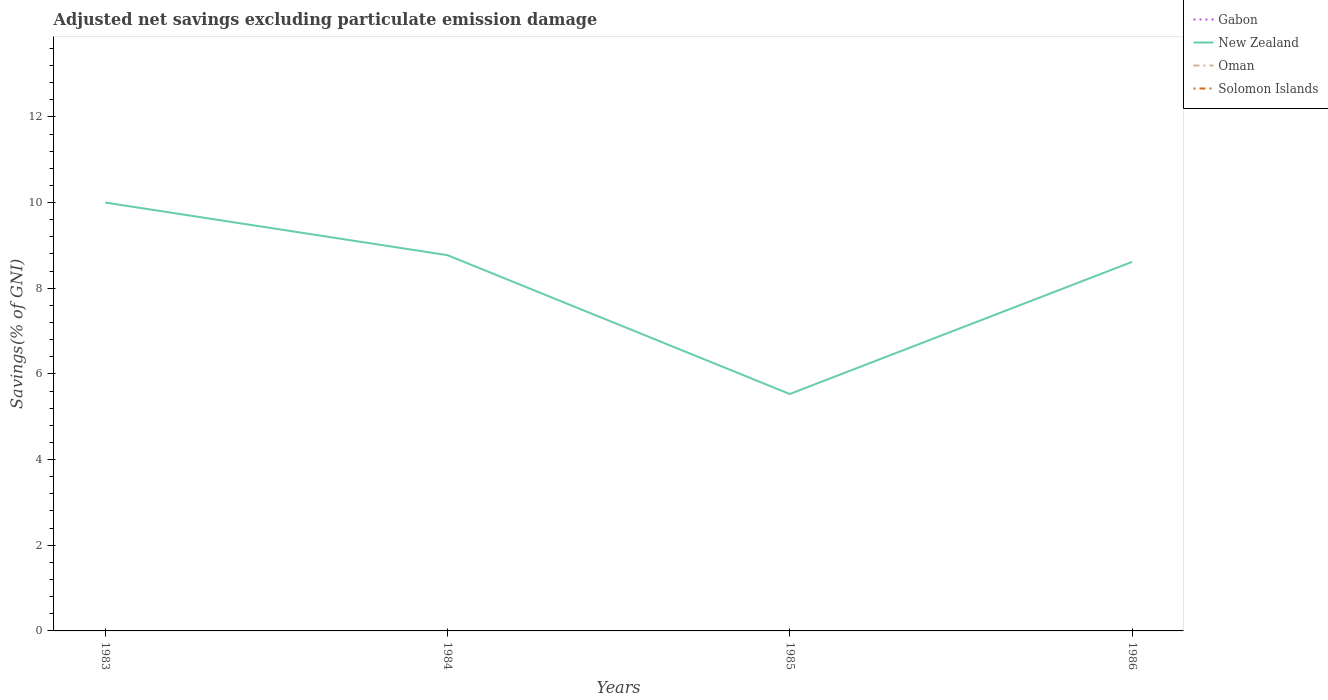Does the line corresponding to Gabon intersect with the line corresponding to New Zealand?
Your answer should be very brief. No. Across all years, what is the maximum adjusted net savings in New Zealand?
Your response must be concise. 5.53. What is the total adjusted net savings in New Zealand in the graph?
Make the answer very short. -3.08. What is the difference between the highest and the second highest adjusted net savings in Oman?
Provide a short and direct response. 0.01. Is the adjusted net savings in New Zealand strictly greater than the adjusted net savings in Solomon Islands over the years?
Provide a short and direct response. No. Are the values on the major ticks of Y-axis written in scientific E-notation?
Offer a very short reply. No. Does the graph contain any zero values?
Provide a succinct answer. Yes. Does the graph contain grids?
Your answer should be very brief. No. How many legend labels are there?
Keep it short and to the point. 4. How are the legend labels stacked?
Offer a very short reply. Vertical. What is the title of the graph?
Provide a short and direct response. Adjusted net savings excluding particulate emission damage. What is the label or title of the Y-axis?
Keep it short and to the point. Savings(% of GNI). What is the Savings(% of GNI) in Gabon in 1983?
Provide a short and direct response. 0. What is the Savings(% of GNI) in New Zealand in 1983?
Make the answer very short. 10. What is the Savings(% of GNI) in Oman in 1983?
Provide a succinct answer. 0. What is the Savings(% of GNI) in Gabon in 1984?
Keep it short and to the point. 0. What is the Savings(% of GNI) in New Zealand in 1984?
Your response must be concise. 8.77. What is the Savings(% of GNI) in Oman in 1984?
Your response must be concise. 0.01. What is the Savings(% of GNI) in Gabon in 1985?
Ensure brevity in your answer.  0. What is the Savings(% of GNI) in New Zealand in 1985?
Make the answer very short. 5.53. What is the Savings(% of GNI) of Gabon in 1986?
Provide a succinct answer. 0. What is the Savings(% of GNI) in New Zealand in 1986?
Ensure brevity in your answer.  8.62. What is the Savings(% of GNI) in Solomon Islands in 1986?
Ensure brevity in your answer.  0. Across all years, what is the maximum Savings(% of GNI) in New Zealand?
Make the answer very short. 10. Across all years, what is the maximum Savings(% of GNI) of Oman?
Provide a succinct answer. 0.01. Across all years, what is the minimum Savings(% of GNI) in New Zealand?
Offer a very short reply. 5.53. Across all years, what is the minimum Savings(% of GNI) in Oman?
Ensure brevity in your answer.  0. What is the total Savings(% of GNI) in Gabon in the graph?
Offer a very short reply. 0. What is the total Savings(% of GNI) of New Zealand in the graph?
Provide a short and direct response. 32.92. What is the total Savings(% of GNI) of Oman in the graph?
Offer a terse response. 0.01. What is the total Savings(% of GNI) in Solomon Islands in the graph?
Provide a succinct answer. 0. What is the difference between the Savings(% of GNI) in New Zealand in 1983 and that in 1984?
Provide a short and direct response. 1.23. What is the difference between the Savings(% of GNI) in New Zealand in 1983 and that in 1985?
Keep it short and to the point. 4.47. What is the difference between the Savings(% of GNI) of New Zealand in 1983 and that in 1986?
Give a very brief answer. 1.39. What is the difference between the Savings(% of GNI) in New Zealand in 1984 and that in 1985?
Your answer should be very brief. 3.24. What is the difference between the Savings(% of GNI) of New Zealand in 1984 and that in 1986?
Ensure brevity in your answer.  0.16. What is the difference between the Savings(% of GNI) in New Zealand in 1985 and that in 1986?
Offer a terse response. -3.08. What is the difference between the Savings(% of GNI) of New Zealand in 1983 and the Savings(% of GNI) of Oman in 1984?
Provide a short and direct response. 9.99. What is the average Savings(% of GNI) of Gabon per year?
Offer a terse response. 0. What is the average Savings(% of GNI) of New Zealand per year?
Provide a succinct answer. 8.23. What is the average Savings(% of GNI) of Oman per year?
Provide a succinct answer. 0. What is the average Savings(% of GNI) in Solomon Islands per year?
Offer a very short reply. 0. In the year 1984, what is the difference between the Savings(% of GNI) in New Zealand and Savings(% of GNI) in Oman?
Your response must be concise. 8.76. What is the ratio of the Savings(% of GNI) of New Zealand in 1983 to that in 1984?
Offer a terse response. 1.14. What is the ratio of the Savings(% of GNI) of New Zealand in 1983 to that in 1985?
Your response must be concise. 1.81. What is the ratio of the Savings(% of GNI) of New Zealand in 1983 to that in 1986?
Your answer should be very brief. 1.16. What is the ratio of the Savings(% of GNI) in New Zealand in 1984 to that in 1985?
Provide a short and direct response. 1.59. What is the ratio of the Savings(% of GNI) of New Zealand in 1984 to that in 1986?
Make the answer very short. 1.02. What is the ratio of the Savings(% of GNI) of New Zealand in 1985 to that in 1986?
Keep it short and to the point. 0.64. What is the difference between the highest and the second highest Savings(% of GNI) of New Zealand?
Your answer should be compact. 1.23. What is the difference between the highest and the lowest Savings(% of GNI) in New Zealand?
Keep it short and to the point. 4.47. What is the difference between the highest and the lowest Savings(% of GNI) in Oman?
Keep it short and to the point. 0.01. 